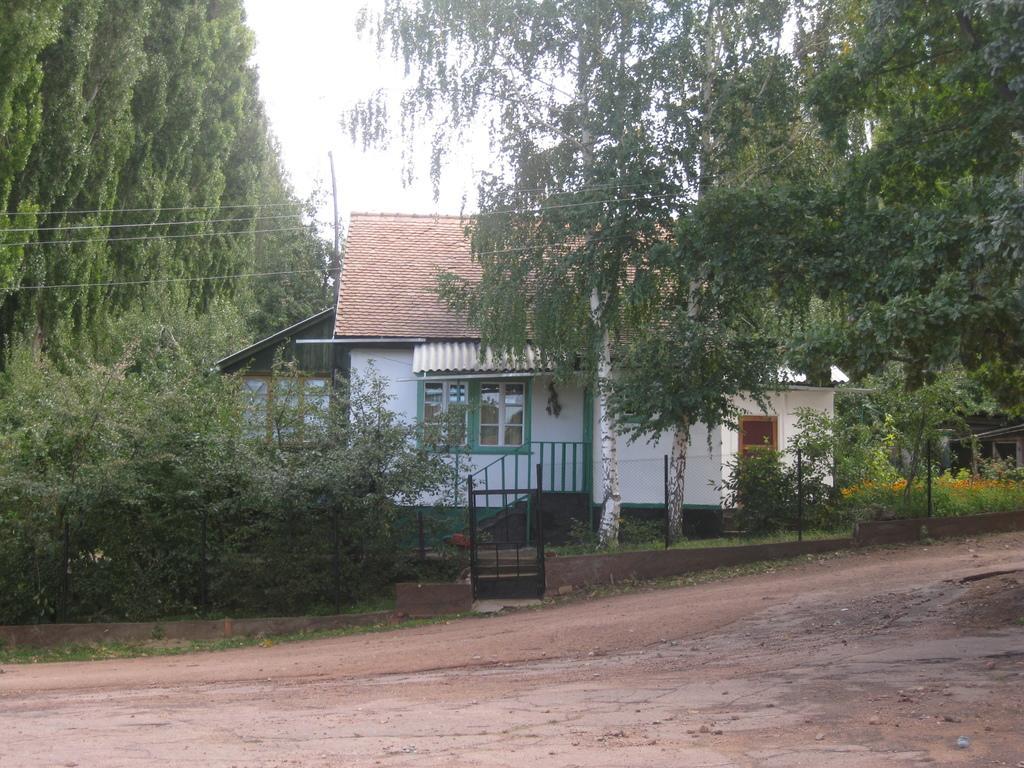Please provide a concise description of this image. In this image there are houses, plants, trees, railing, electrical poles with cables. At the top of the image there is sky. 